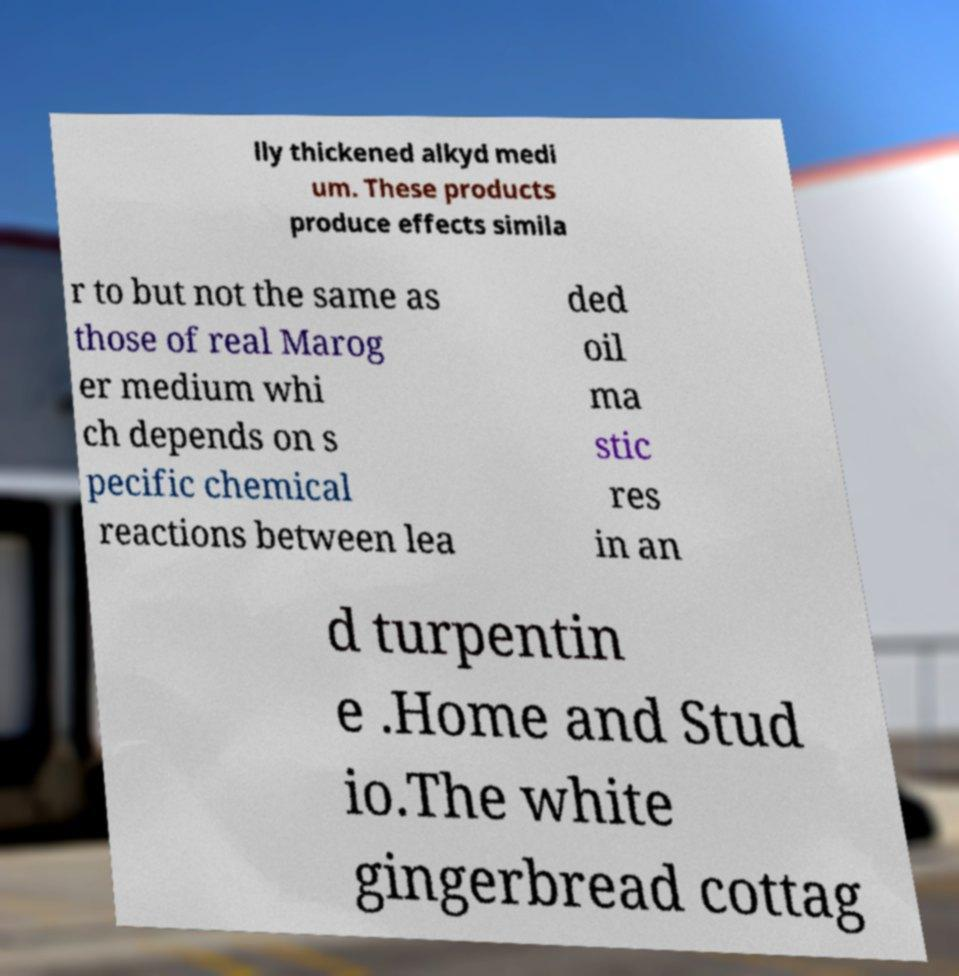Can you read and provide the text displayed in the image?This photo seems to have some interesting text. Can you extract and type it out for me? lly thickened alkyd medi um. These products produce effects simila r to but not the same as those of real Marog er medium whi ch depends on s pecific chemical reactions between lea ded oil ma stic res in an d turpentin e .Home and Stud io.The white gingerbread cottag 